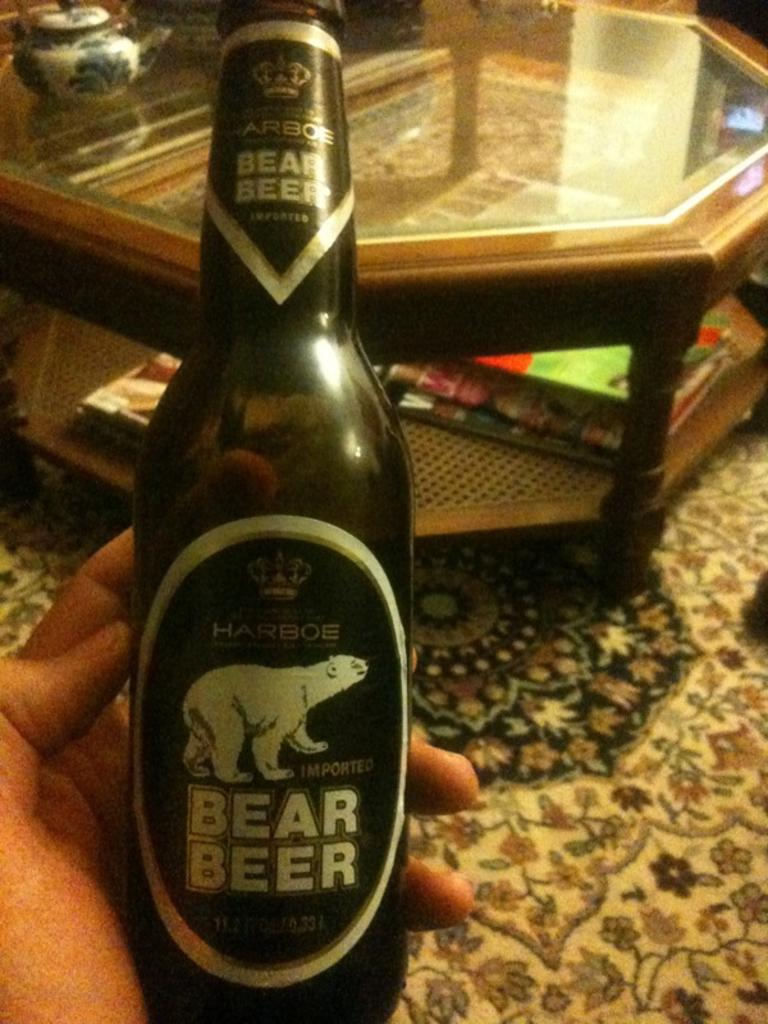What is the person holding in the image? There is a person's hand holding a bottle in the image. What can be seen in the background of the image? There is a table in the background of the image. What items are on the table in the background? There are books and a utensil on the table in the background. What type of leaf is being used as apparel in the image? There is no leaf or apparel present in the image. How many marks can be seen on the utensil in the image? There is no mention of marks on the utensil in the image; only its presence on the table is noted. 